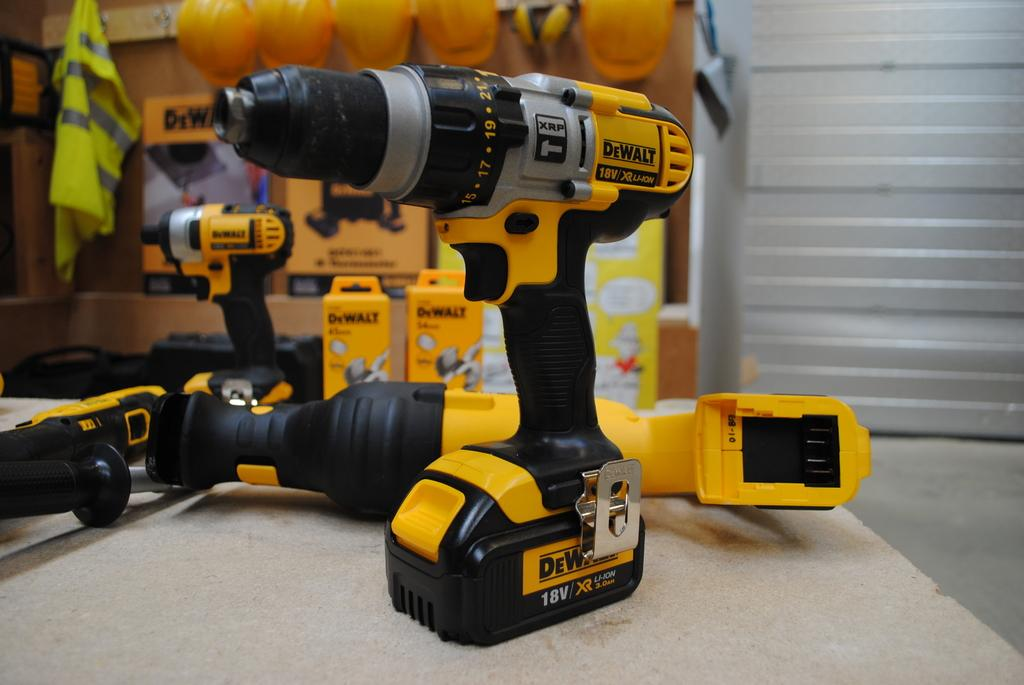What type of machinery is present in the image? There are drilling machines in the image. Can you describe the background of the image? The background is blurred. What safety equipment can be seen in the background? There are helmets in the background. What other objects are present in the background? There are boxes and other objects in the background. Where is the window blind located in the image? The window blind is on the right side of the image. What type of thrill can be experienced by playing basketball in the image? There is no basketball or any indication of a basketball court in the image. 